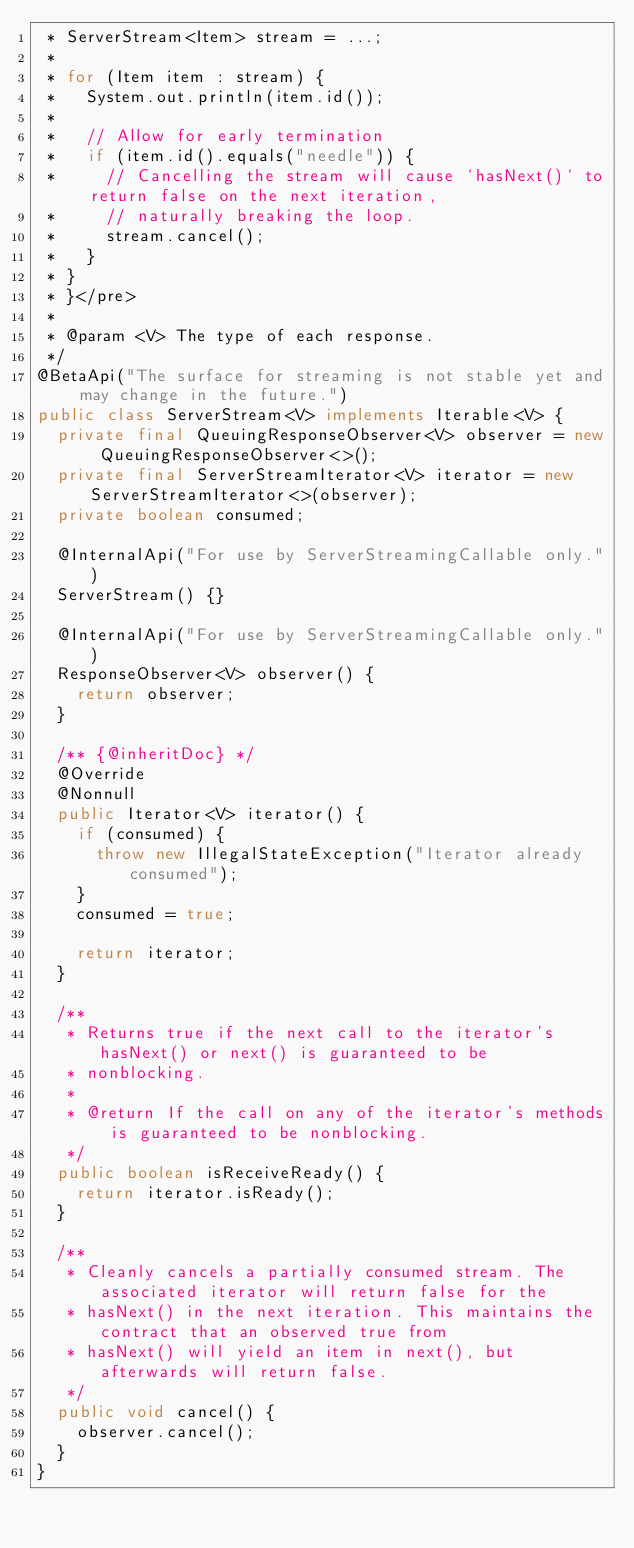<code> <loc_0><loc_0><loc_500><loc_500><_Java_> * ServerStream<Item> stream = ...;
 *
 * for (Item item : stream) {
 *   System.out.println(item.id());
 *
 *   // Allow for early termination
 *   if (item.id().equals("needle")) {
 *     // Cancelling the stream will cause `hasNext()` to return false on the next iteration,
 *     // naturally breaking the loop.
 *     stream.cancel();
 *   }
 * }
 * }</pre>
 *
 * @param <V> The type of each response.
 */
@BetaApi("The surface for streaming is not stable yet and may change in the future.")
public class ServerStream<V> implements Iterable<V> {
  private final QueuingResponseObserver<V> observer = new QueuingResponseObserver<>();
  private final ServerStreamIterator<V> iterator = new ServerStreamIterator<>(observer);
  private boolean consumed;

  @InternalApi("For use by ServerStreamingCallable only.")
  ServerStream() {}

  @InternalApi("For use by ServerStreamingCallable only.")
  ResponseObserver<V> observer() {
    return observer;
  }

  /** {@inheritDoc} */
  @Override
  @Nonnull
  public Iterator<V> iterator() {
    if (consumed) {
      throw new IllegalStateException("Iterator already consumed");
    }
    consumed = true;

    return iterator;
  }

  /**
   * Returns true if the next call to the iterator's hasNext() or next() is guaranteed to be
   * nonblocking.
   *
   * @return If the call on any of the iterator's methods is guaranteed to be nonblocking.
   */
  public boolean isReceiveReady() {
    return iterator.isReady();
  }

  /**
   * Cleanly cancels a partially consumed stream. The associated iterator will return false for the
   * hasNext() in the next iteration. This maintains the contract that an observed true from
   * hasNext() will yield an item in next(), but afterwards will return false.
   */
  public void cancel() {
    observer.cancel();
  }
}
</code> 